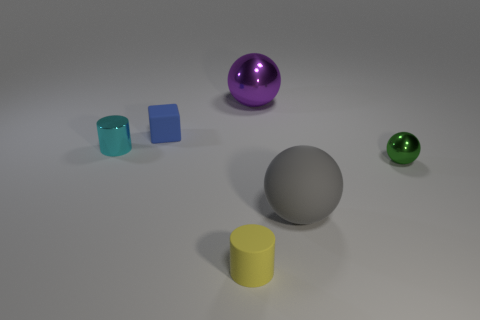How many objects are there in total in the image? There are five objects in the image. Including a purple sphere, a gray sphere, a green sphere, a blue cube, and a yellow cylinder. 